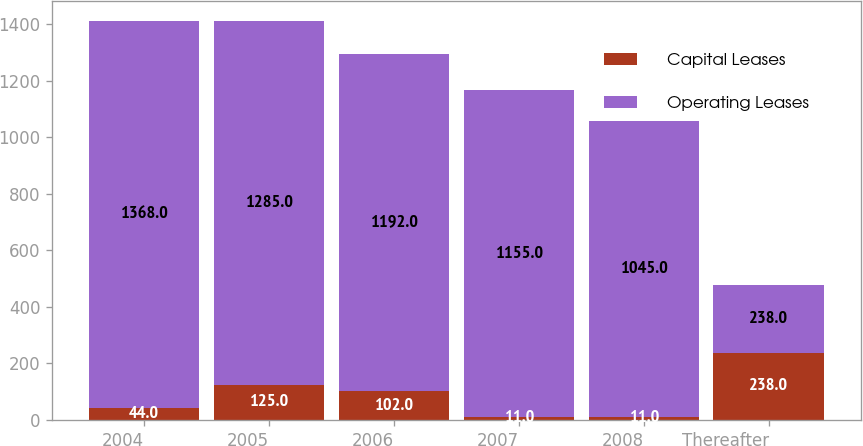<chart> <loc_0><loc_0><loc_500><loc_500><stacked_bar_chart><ecel><fcel>2004<fcel>2005<fcel>2006<fcel>2007<fcel>2008<fcel>Thereafter<nl><fcel>Capital Leases<fcel>44<fcel>125<fcel>102<fcel>11<fcel>11<fcel>238<nl><fcel>Operating Leases<fcel>1368<fcel>1285<fcel>1192<fcel>1155<fcel>1045<fcel>238<nl></chart> 